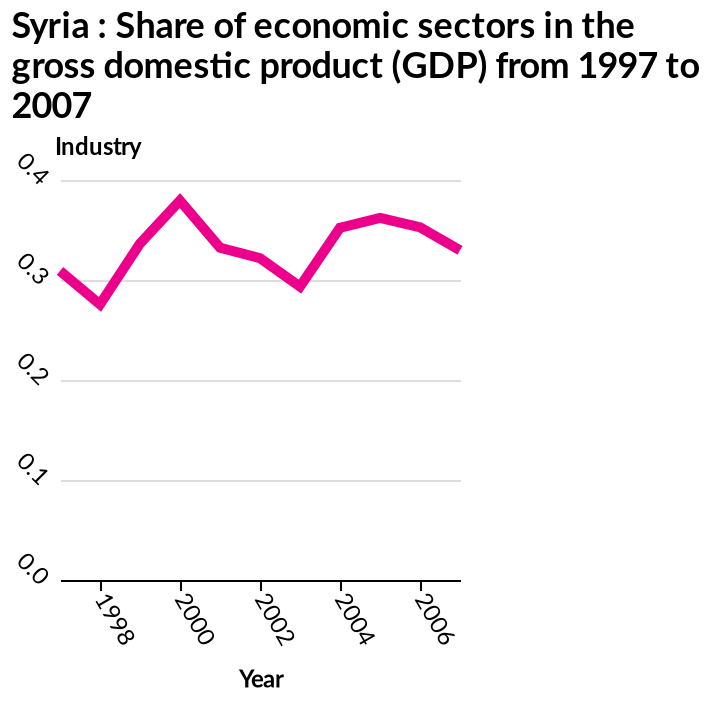<image>
What is the time period covered by the line plot? The line plot shows data from 1997 to 2007, representing a time period of 11 years. What is the range of the x-axis? The x-axis has a range from 1998 to 2006, with a minimum of 1998 and a maximum of 2006. Were there any major increases in the industry as a share of economic sectors in the gross domestic products in Syria between 1997-2007? No, there were no major increases in the industry as a share of economic sectors in the gross domestic products in Syria between 1997-2007. 